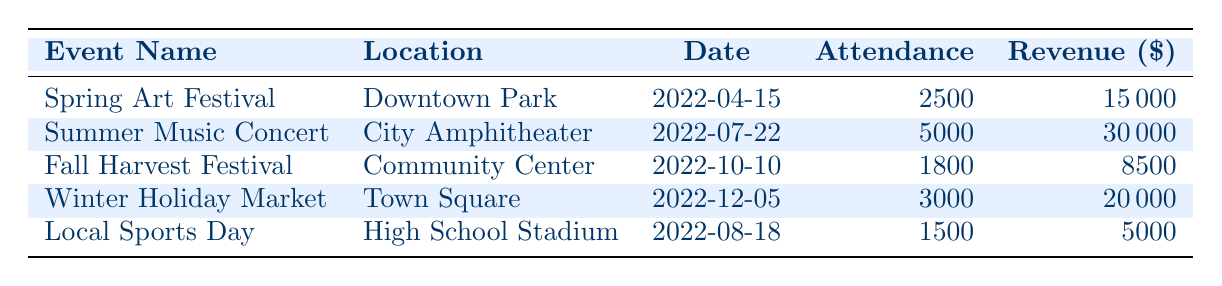What was the attendance at the Summer Music Concert? From the table, the attendance for the Summer Music Concert is listed directly under that event. It shows an attendance of 5000.
Answer: 5000 Which event generated the highest revenue? By looking at the revenue column, we compare the values. The Summer Music Concert has the highest revenue at 30000, which is more than the revenue of all other events.
Answer: Summer Music Concert What is the total attendance for all events? To find the total attendance, I add the attendance numbers for all events: 2500 + 5000 + 1800 + 3000 + 1500 = 13800.
Answer: 13800 Did the Winter Holiday Market have higher attendance than the Fall Harvest Festival? Comparing the attendance numbers, the Winter Holiday Market had an attendance of 3000, while the Fall Harvest Festival had 1800. Since 3000 is greater than 1800, the statement is true.
Answer: Yes What is the average revenue per event? To find the average revenue, sum the revenues (15000 + 30000 + 8500 + 20000 + 5000 = 78500) and then divide by the number of events (5): 78500 / 5 = 15700.
Answer: 15700 Which event took place earliest in the year? The dates provided help to determine that the Spring Art Festival, occurring on 2022-04-15, is the earliest event when compared to the dates of the other events.
Answer: Spring Art Festival Is the revenue from the Fall Harvest Festival greater than the revenue from Local Sports Day? The revenue for the Fall Harvest Festival is 8500 and for Local Sports Day is 5000. Since 8500 is greater than 5000, the statement is true.
Answer: Yes How much more revenue did the Summer Music Concert generate compared to Local Sports Day? To find the difference, subtract the revenue of Local Sports Day (5000) from that of the Summer Music Concert (30000): 30000 - 5000 = 25000.
Answer: 25000 What location had the event with the second highest attendance? After checking the attendance figures, the Summer Music Concert with 5000 has the highest attendance, and the Winter Holiday Market comes next with 3000, making Town Square the location for the second highest attendance event.
Answer: Town Square 